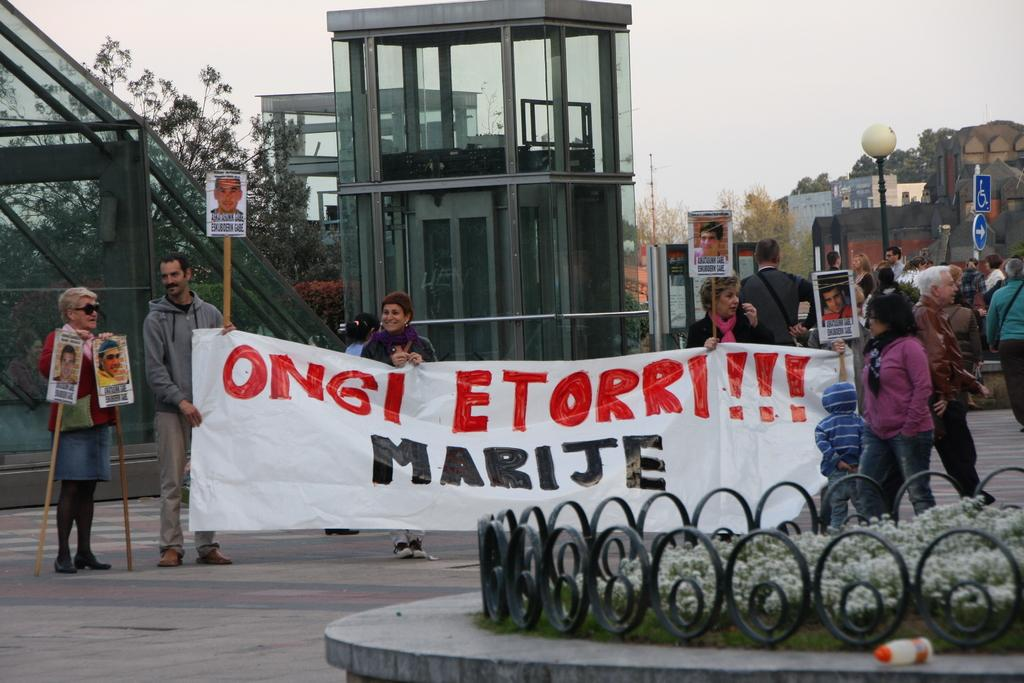What are the people in the image holding? The people in the image are holding boards. What can be seen hanging in the image? There is a banner and a flag in the image. What type of natural element is present in the image? There is a tree in the image. What architectural feature can be seen in the image? There is a light pole in the image. What type of structures are visible in the image? There are buildings in the image. What is the color of the sky in the image? The sky is visible in the image, but the color is not mentioned in the facts. What type of vegetation is present in the image? There are plants in the image. What type of barrier is present in the image? There is a grille in the image. What type of container is present in the image? There is a bottle in the image. What type of wall is present in the image? There are glass walls in the image. What type of texture can be seen on the flag in the image? The facts provided do not mention the texture of the flag, so we cannot determine the texture from the image. How does the light pole curve in the image? The facts provided do not mention any curves in the light pole, so we cannot determine if it curves from the image. 